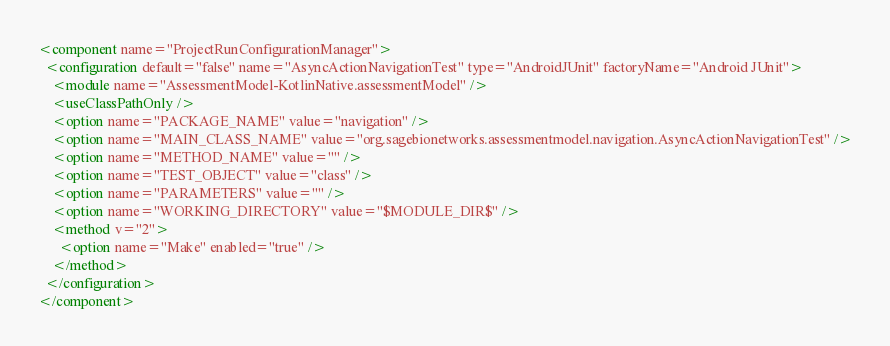<code> <loc_0><loc_0><loc_500><loc_500><_XML_><component name="ProjectRunConfigurationManager">
  <configuration default="false" name="AsyncActionNavigationTest" type="AndroidJUnit" factoryName="Android JUnit">
    <module name="AssessmentModel-KotlinNative.assessmentModel" />
    <useClassPathOnly />
    <option name="PACKAGE_NAME" value="navigation" />
    <option name="MAIN_CLASS_NAME" value="org.sagebionetworks.assessmentmodel.navigation.AsyncActionNavigationTest" />
    <option name="METHOD_NAME" value="" />
    <option name="TEST_OBJECT" value="class" />
    <option name="PARAMETERS" value="" />
    <option name="WORKING_DIRECTORY" value="$MODULE_DIR$" />
    <method v="2">
      <option name="Make" enabled="true" />
    </method>
  </configuration>
</component></code> 